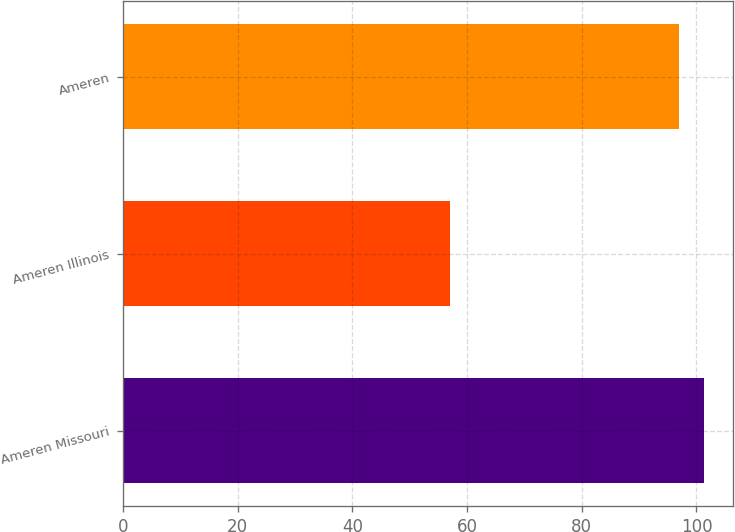<chart> <loc_0><loc_0><loc_500><loc_500><bar_chart><fcel>Ameren Missouri<fcel>Ameren Illinois<fcel>Ameren<nl><fcel>101.3<fcel>57<fcel>97<nl></chart> 